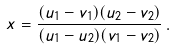Convert formula to latex. <formula><loc_0><loc_0><loc_500><loc_500>x = \frac { ( u _ { 1 } - v _ { 1 } ) ( u _ { 2 } - v _ { 2 } ) } { ( u _ { 1 } - u _ { 2 } ) ( v _ { 1 } - v _ { 2 } ) } \, .</formula> 